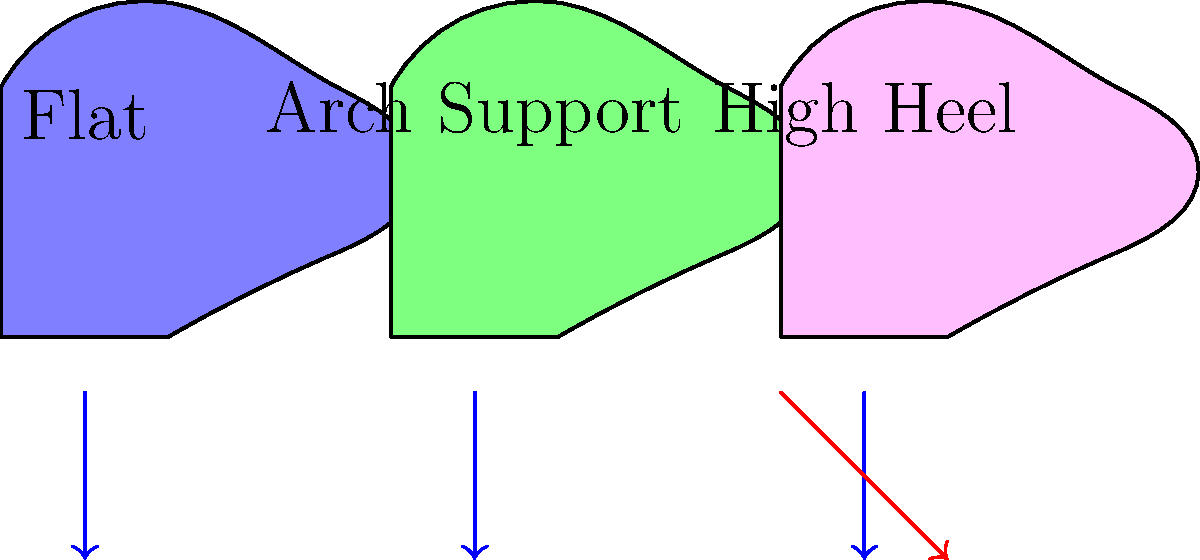As a social worker investigating a case, you come across footprints at the scene. Based on the biomechanical impact of different shoe types shown in the diagram, which type of shoe is most likely to cause increased pressure on the forefoot and potentially lead to more distinct toe impressions in the footprint? To answer this question, we need to consider the biomechanical impact of each shoe type:

1. Flat shoes:
   - Distribute weight evenly across the foot
   - Minimal alteration to natural foot position
   - Force is mainly vertical (blue arrow)

2. Arch support shoes:
   - Provide support to the arch of the foot
   - Distribute weight more evenly between heel and forefoot
   - Force is mainly vertical (blue arrow)

3. High heels:
   - Elevate the heel significantly above the forefoot
   - Shift body weight forward
   - Increase pressure on the forefoot and toes
   - Have both vertical (blue arrow) and forward (red arrow) force components

The high heel shoe causes the following biomechanical changes:
   - The center of gravity shifts forward
   - More weight is placed on the ball of the foot and toes
   - The ankle is forced into plantar flexion (toes pointed downward)

These changes result in:
   - Increased pressure on the forefoot and toes
   - More pronounced toe gripping to maintain balance
   - Potentially deeper and more distinct toe impressions in footprints

Therefore, high heels are most likely to cause increased pressure on the forefoot and lead to more distinct toe impressions in the footprint.
Answer: High heels 